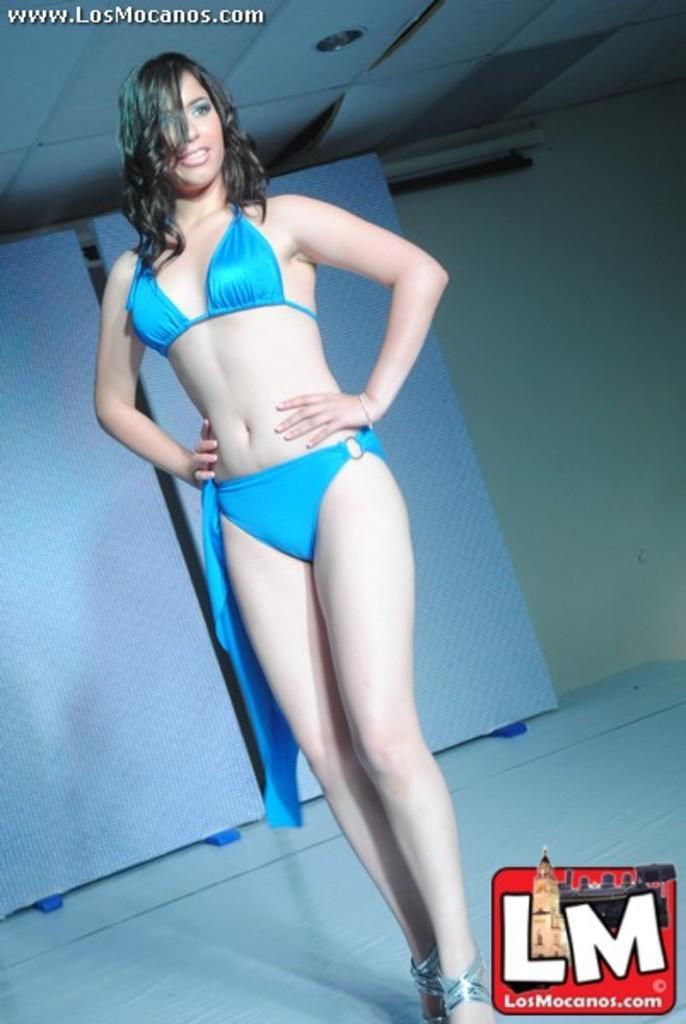Can you describe this image briefly? In this picture we can see a woman is standing and smiling, at the right bottom there is a logo, we can see some text at the left top of the picture, in the background there is a wall, there is the ceiling and a light at the top of the picture. 